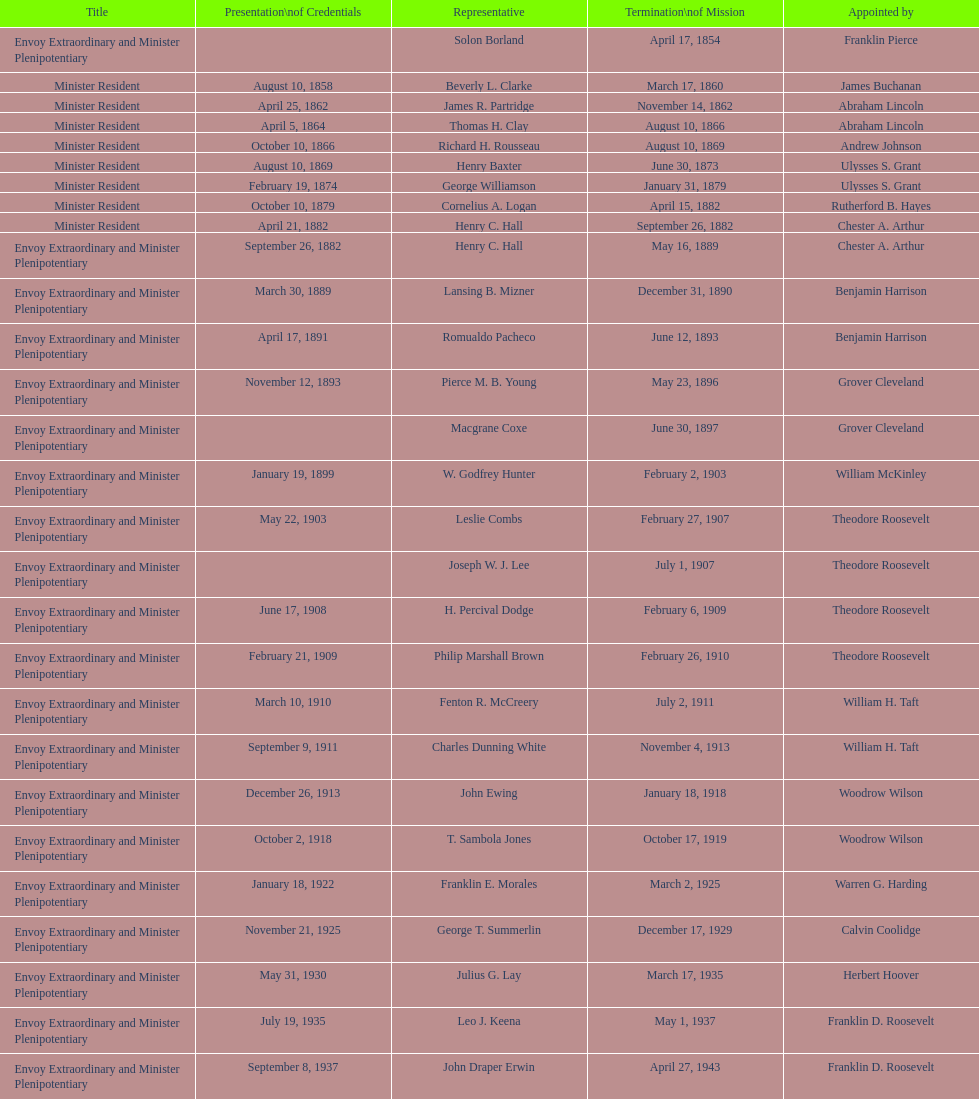Which date is below april 17, 1854 March 17, 1860. 